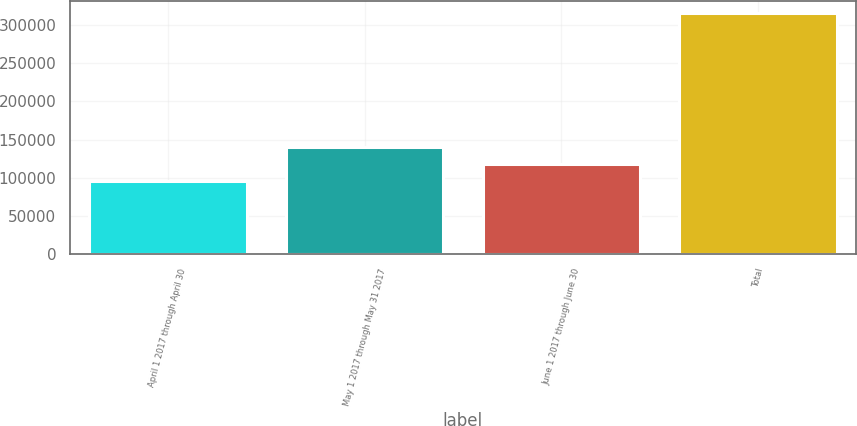<chart> <loc_0><loc_0><loc_500><loc_500><bar_chart><fcel>April 1 2017 through April 30<fcel>May 1 2017 through May 31 2017<fcel>June 1 2017 through June 30<fcel>Total<nl><fcel>96400<fcel>140184<fcel>118292<fcel>315319<nl></chart> 